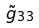Convert formula to latex. <formula><loc_0><loc_0><loc_500><loc_500>\tilde { g } _ { 3 3 }</formula> 